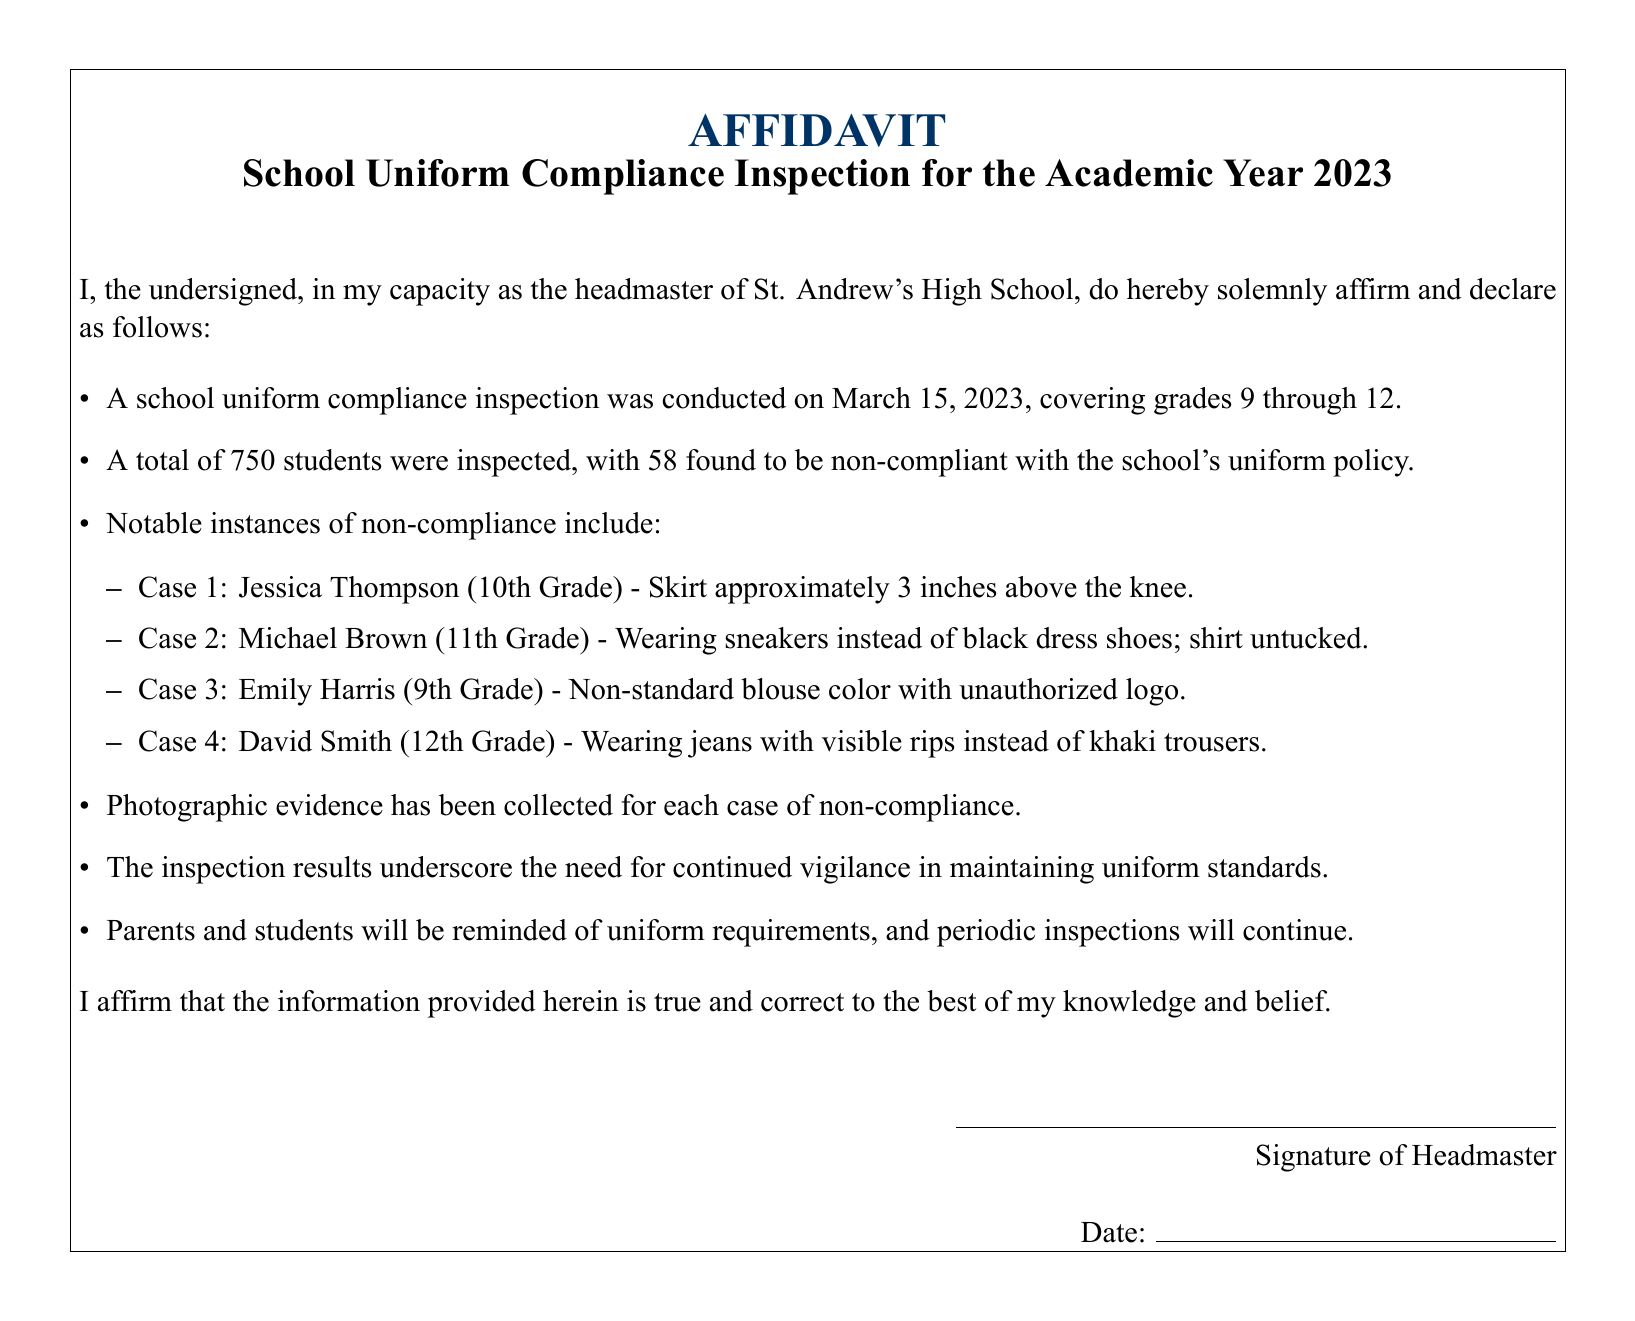what was the date of the inspection? The date of the inspection is explicitly stated in the document, which is March 15, 2023.
Answer: March 15, 2023 how many students were inspected? The document specifies that a total of 750 students were inspected during the compliance check.
Answer: 750 how many students were non-compliant? The number of students found to be non-compliant with the uniform policy is clearly mentioned in the document as 58.
Answer: 58 who was the headmaster? The document identifies the headmaster involved in the affidavit as the undersigned, defined as the headmaster of St. Andrew's High School.
Answer: St. Andrew's High School what violation did Jessica Thompson have? The document describes Jessica Thompson's violation as a skirt that was approximately 3 inches above the knee.
Answer: Skirt approximately 3 inches above the knee what type of shoes was Michael Brown wearing? The document notes that Michael Brown was wearing sneakers instead of the required black dress shoes.
Answer: Sneakers instead of black dress shoes what will the school do after the inspection? The document states that parents and students will be reminded of uniform requirements as a post-inspection action.
Answer: Remind of uniform requirements what evidence was collected during the inspection? The document clearly mentions that photographic evidence has been collected for each case of non-compliance noted.
Answer: Photographic evidence what is the main purpose of the affidavit? The main purpose of the affidavit is to affirm the results of the school uniform compliance inspection and declare adherence to established uniform standards.
Answer: Affirm inspection results and adherence to standards 